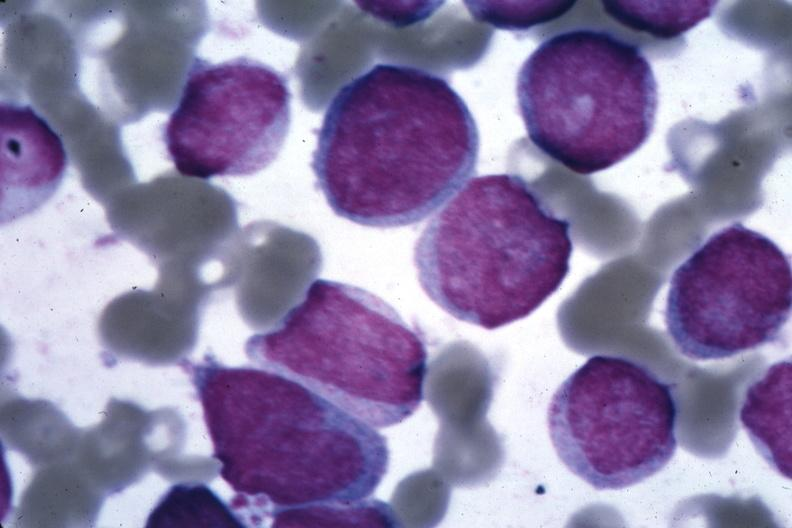s interesting case present?
Answer the question using a single word or phrase. No 